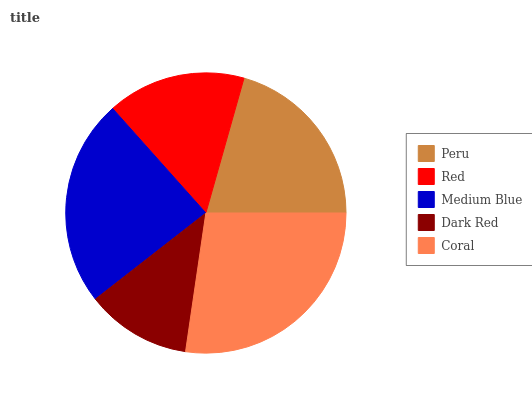Is Dark Red the minimum?
Answer yes or no. Yes. Is Coral the maximum?
Answer yes or no. Yes. Is Red the minimum?
Answer yes or no. No. Is Red the maximum?
Answer yes or no. No. Is Peru greater than Red?
Answer yes or no. Yes. Is Red less than Peru?
Answer yes or no. Yes. Is Red greater than Peru?
Answer yes or no. No. Is Peru less than Red?
Answer yes or no. No. Is Peru the high median?
Answer yes or no. Yes. Is Peru the low median?
Answer yes or no. Yes. Is Dark Red the high median?
Answer yes or no. No. Is Dark Red the low median?
Answer yes or no. No. 